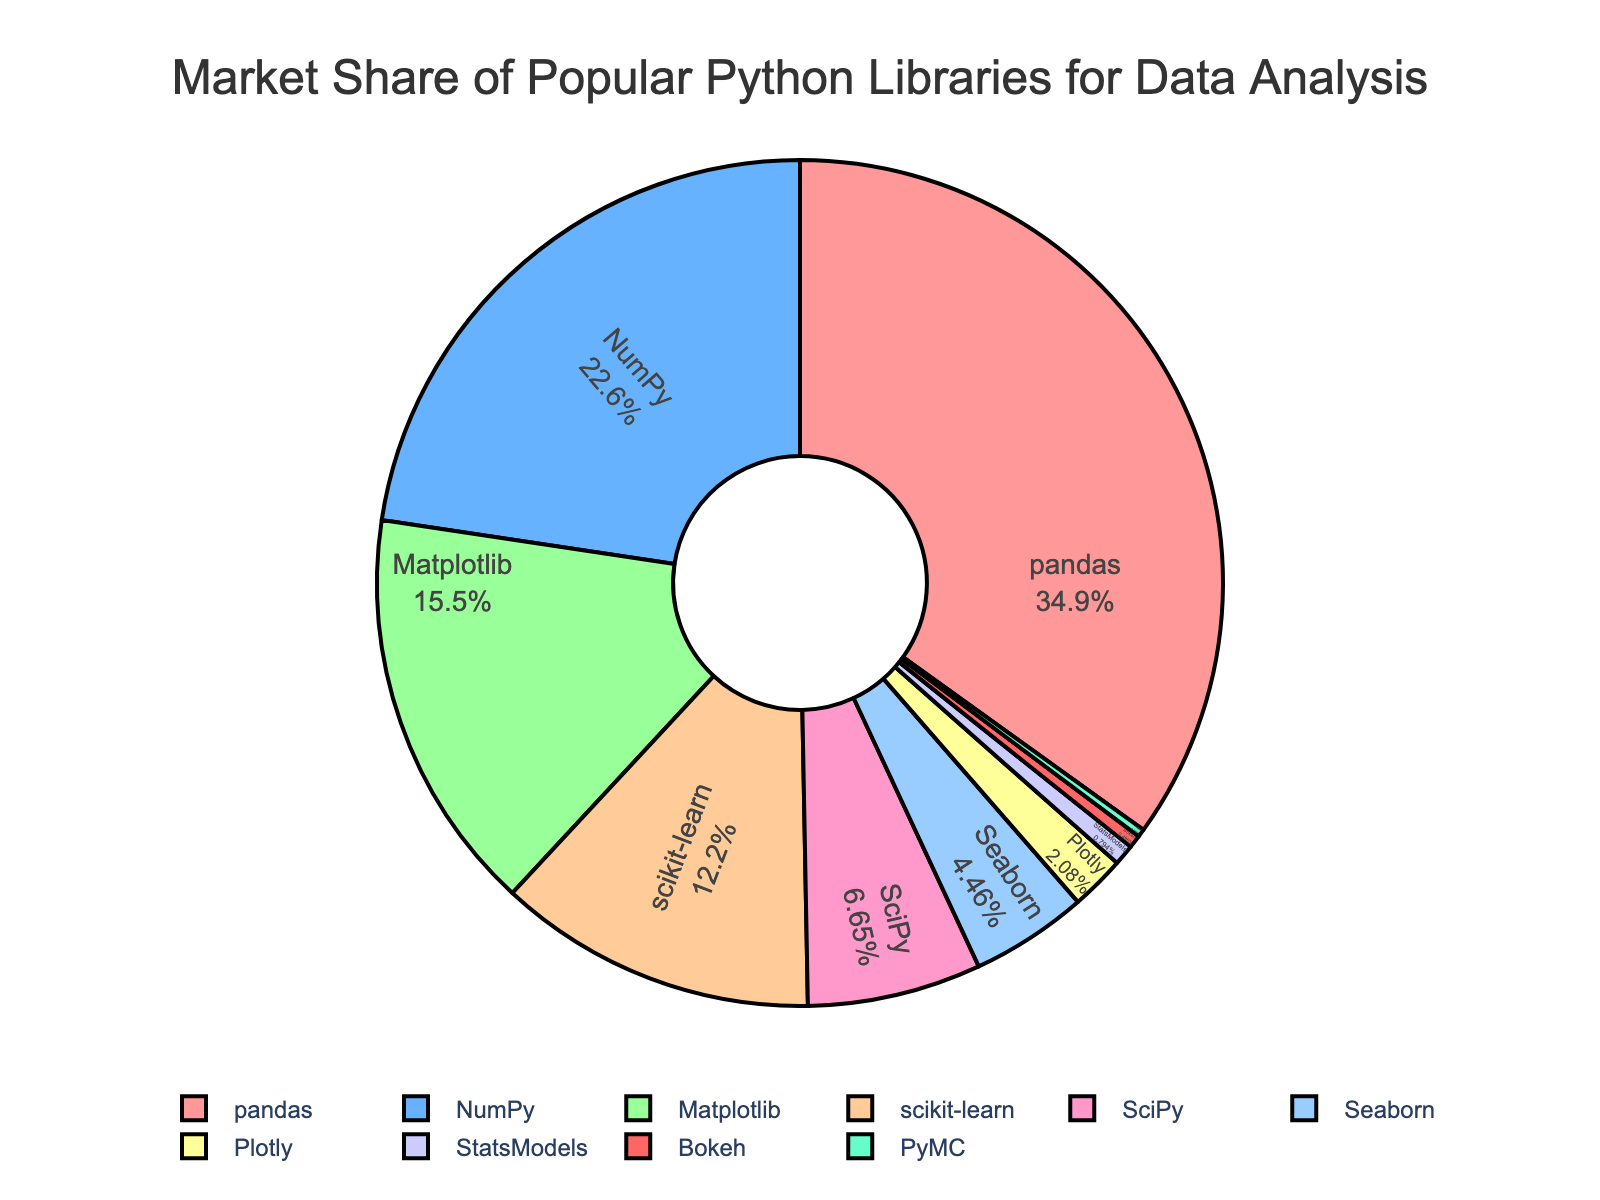What is the market share of the three most popular Python libraries for data analysis combined? The three most popular libraries are pandas, NumPy, and Matplotlib. Their market shares are 35.2%, 22.8%, and 15.6% respectively. Adding these together: 35.2 + 22.8 + 15.6 = 73.6%.
Answer: 73.6% Which library has the smallest market share, and what is its percentage? By looking at the pie chart, PyMC has the smallest visual section. Its market share is 0.3%.
Answer: PyMC, 0.3% Which two libraries have the closest market shares, and what are they? Compare the values for all libraries to find the closest pair. SciPy (6.7%) and Seaborn (4.5%) have a difference of 2.2%, which is the smallest difference among pairs.
Answer: SciPy and Seaborn Is StatModels' market share greater than or less than 1%? By examining the pie chart and noting that StatModels has a market share of 0.8%, which is less than 1%.
Answer: Less than 1% How much larger is pandas' market share compared to NumPy? Pandas has a market share of 35.2% and NumPy has 22.8%. Subtract NumPy's share from pandas' share: 35.2 - 22.8 = 12.4%. So, pandas' share is 12.4% larger than NumPy's.
Answer: 12.4% What is the combined market share of the bottom three libraries? The bottom three libraries are StatsModels (0.8%), Bokeh (0.5%), and PyMC (0.3%). Adding these together gives: 0.8 + 0.5 + 0.3 = 1.6%.
Answer: 1.6% Which library is represented by the red segment in the pie chart? The pie chart's red segment represents the most popular library, which is pandas with a market share of 35.2%.
Answer: pandas How does the market share of Matplotlib compare to that of scikit-learn? Matplotlib has a market share of 15.6%, while scikit-learn has 12.3%. Therefore, Matplotlib's share is greater than scikit-learn's.
Answer: Matplotlib's share is greater If we combine the market shares of every library that has less than 10% share, what is their total market share? Libraries with less than 10% share are SciPy (6.7%), Seaborn (4.5%), Plotly (2.1%), StatsModels (0.8%), Bokeh (0.5%), and PyMC (0.3%). Adding these together: 6.7 + 4.5 + 2.1 + 0.8 + 0.5 + 0.3 = 14.9%.
Answer: 14.9% Which library has a market share closest to 5%? By examining the chart, SciPy (6.7%) is the closest to 5%.
Answer: SciPy 